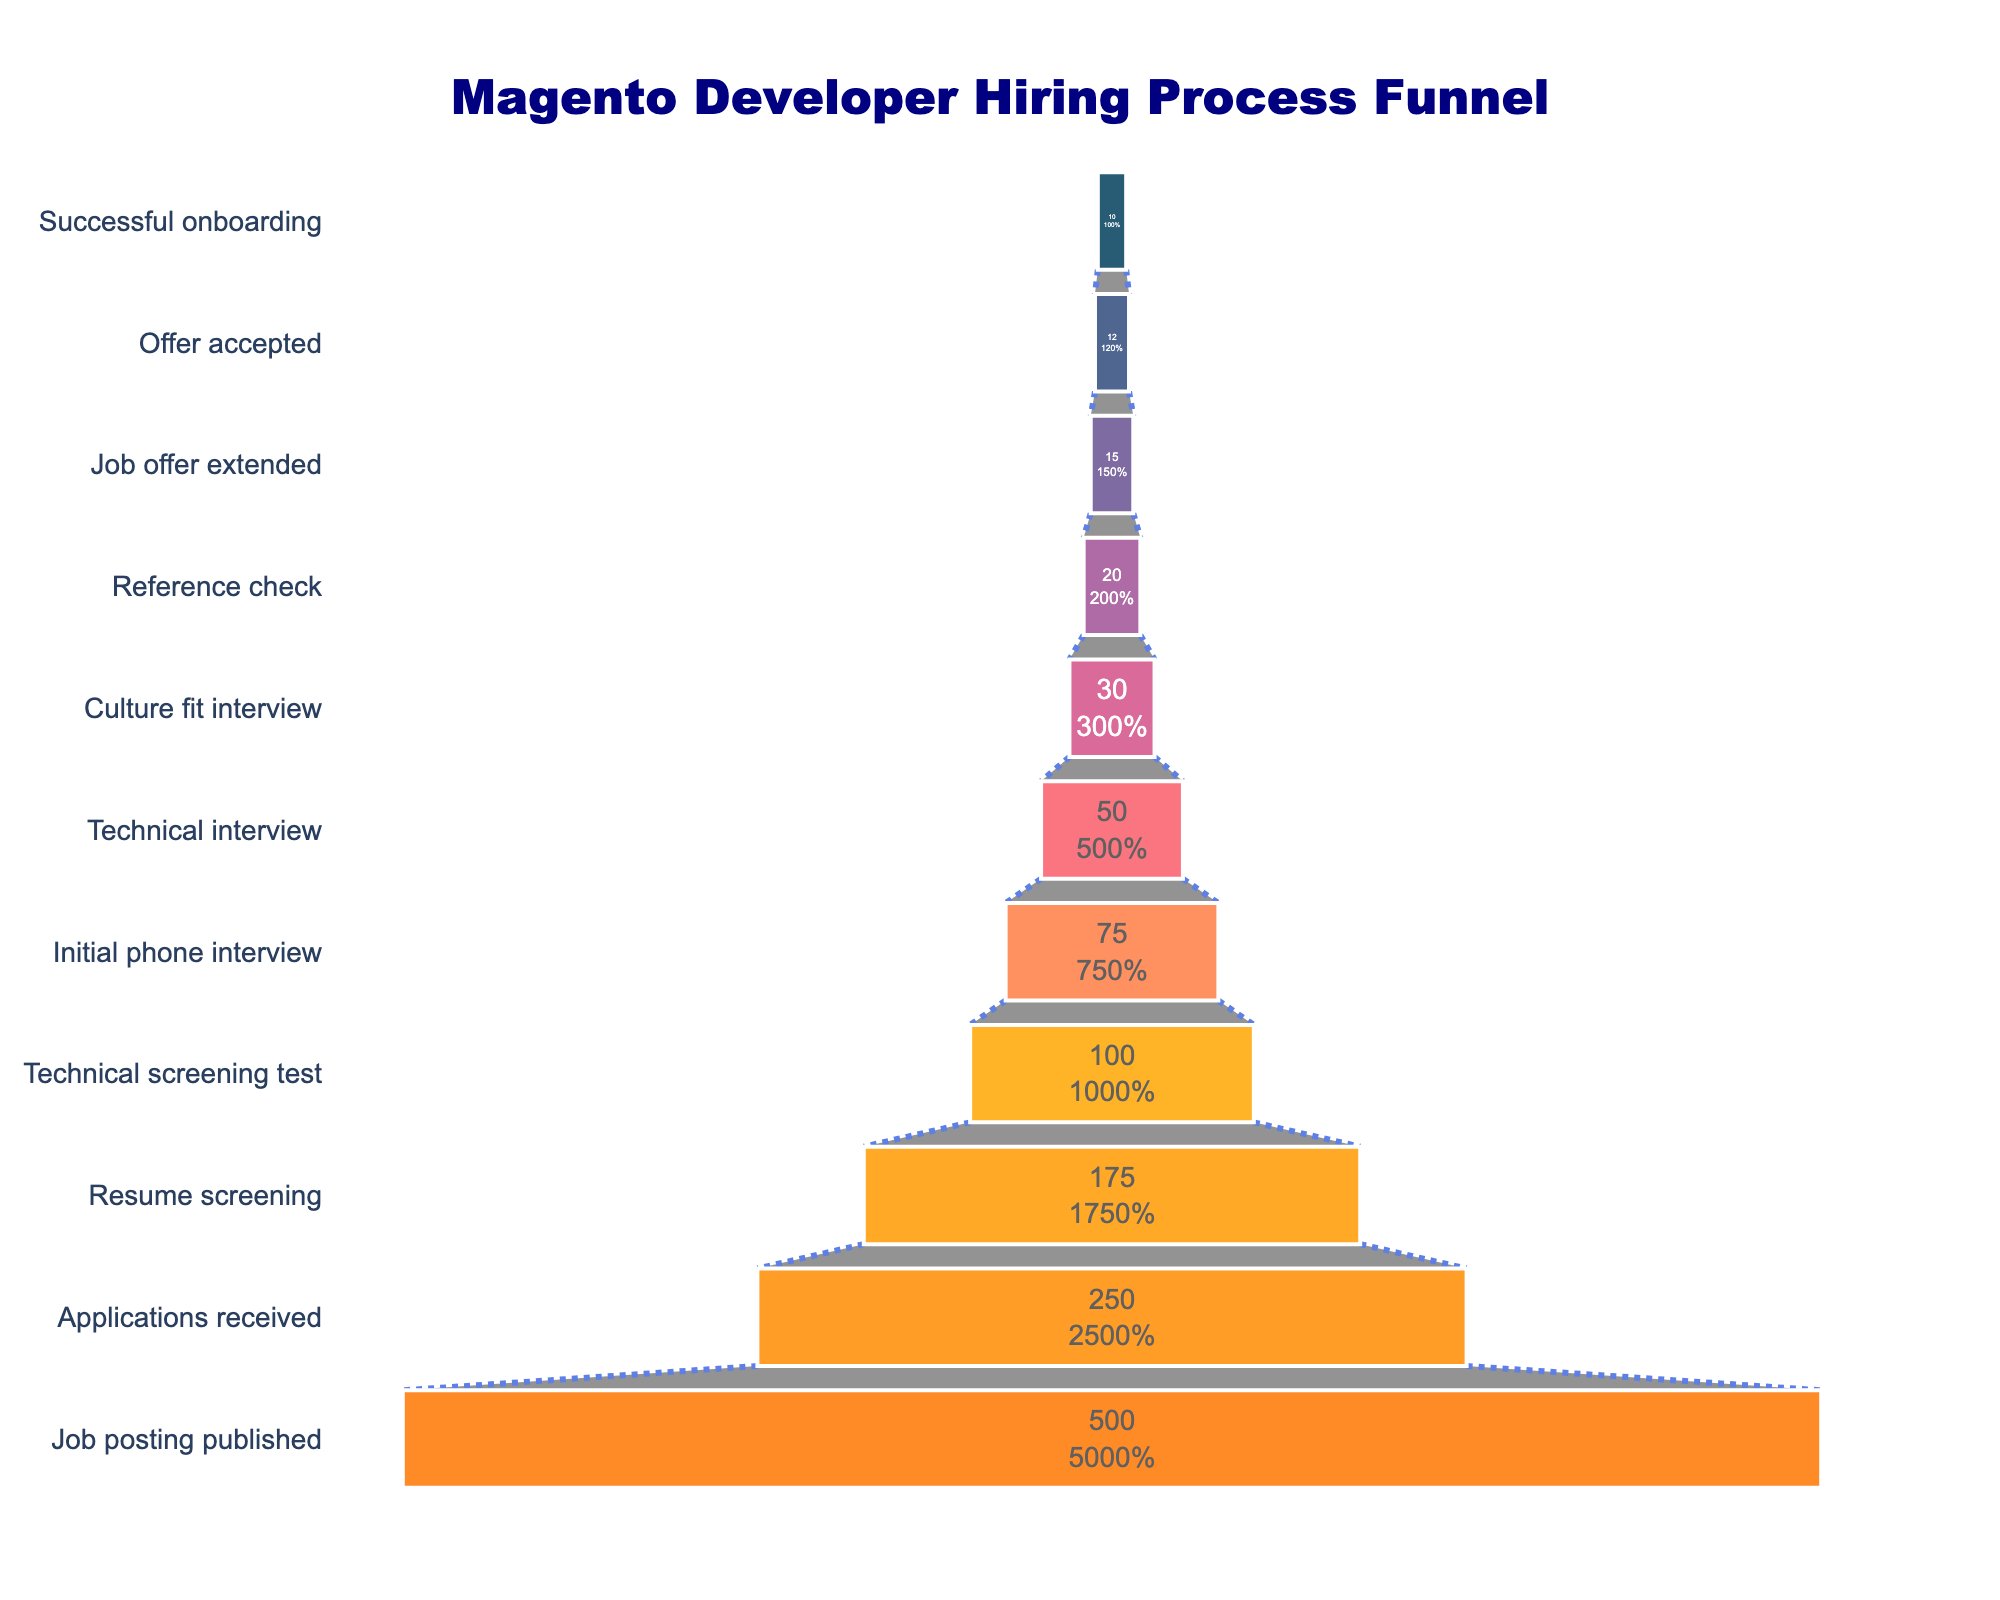What is the title of the funnel chart? The title of the chart is clearly indicated at the top.
Answer: "Magento Developer Hiring Process Funnel" How many stages are there in the hiring process? To find the number of stages, count all the different stages listed in the funnel chart.
Answer: 11 How many candidates successfully onboarded? Look at the number at the bottom of the funnel where it indicates successful onboarding.
Answer: 10 Which stage has the highest number of candidates? Identify the numerical value associated with each stage and determine the highest number.
Answer: Job posting published How many candidates passed the initial phone interview? Locate the "Initial phone interview" stage and note the number of candidates at this stage.
Answer: 75 What is the difference in the number of candidates between the Job offer extended and the Offer accepted stages? Subtract the number of candidates who accepted the offer from those to whom job offers were extended (15 - 12).
Answer: 3 What is the percentage of candidates that moved from resume screening to technical screening test? Calculate by dividing the number of candidates in the technical screening test by the number of candidates in resume screening, then multiply by 100 (100 / 175 * 100).
Answer: 57.1% How many more candidates completed the technical screening test compared to the culture fit interview? Subtract the number of candidates in the culture fit interview from those in the technical screening test (100 - 30).
Answer: 70 Comparing the initial phone interview stage and the reference check stage, by how much did the candidate count decrease? Subtract the number of candidates in the reference check stage from those in the initial phone interview stage (75 - 20).
Answer: 55 What is the ratio of candidates who received a job offer to those who successfully onboarded? Calculate the ratio by dividing the number of candidates who successfully onboarded by those who received a job offer (10 / 15).
Answer: 2:3 